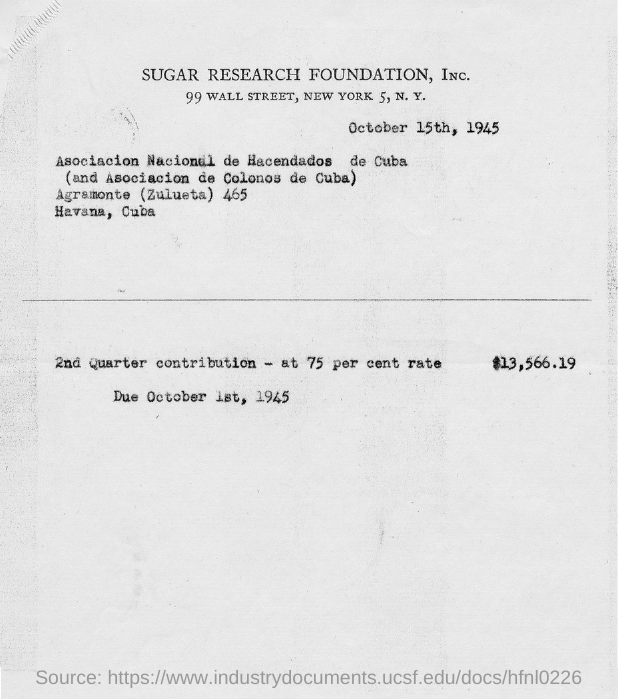Indicate a few pertinent items in this graphic. The due date is October 1st, 1945. The document is dated October 15th, 1945. 